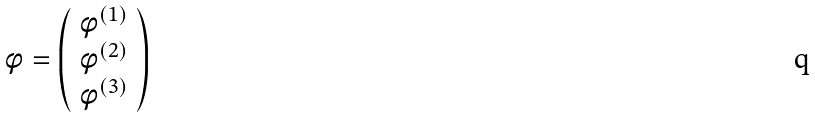<formula> <loc_0><loc_0><loc_500><loc_500>\phi = \left ( \begin{array} { l } \phi ^ { ( 1 ) } \\ \phi ^ { ( 2 ) } \\ \phi ^ { ( 3 ) } \end{array} \right )</formula> 